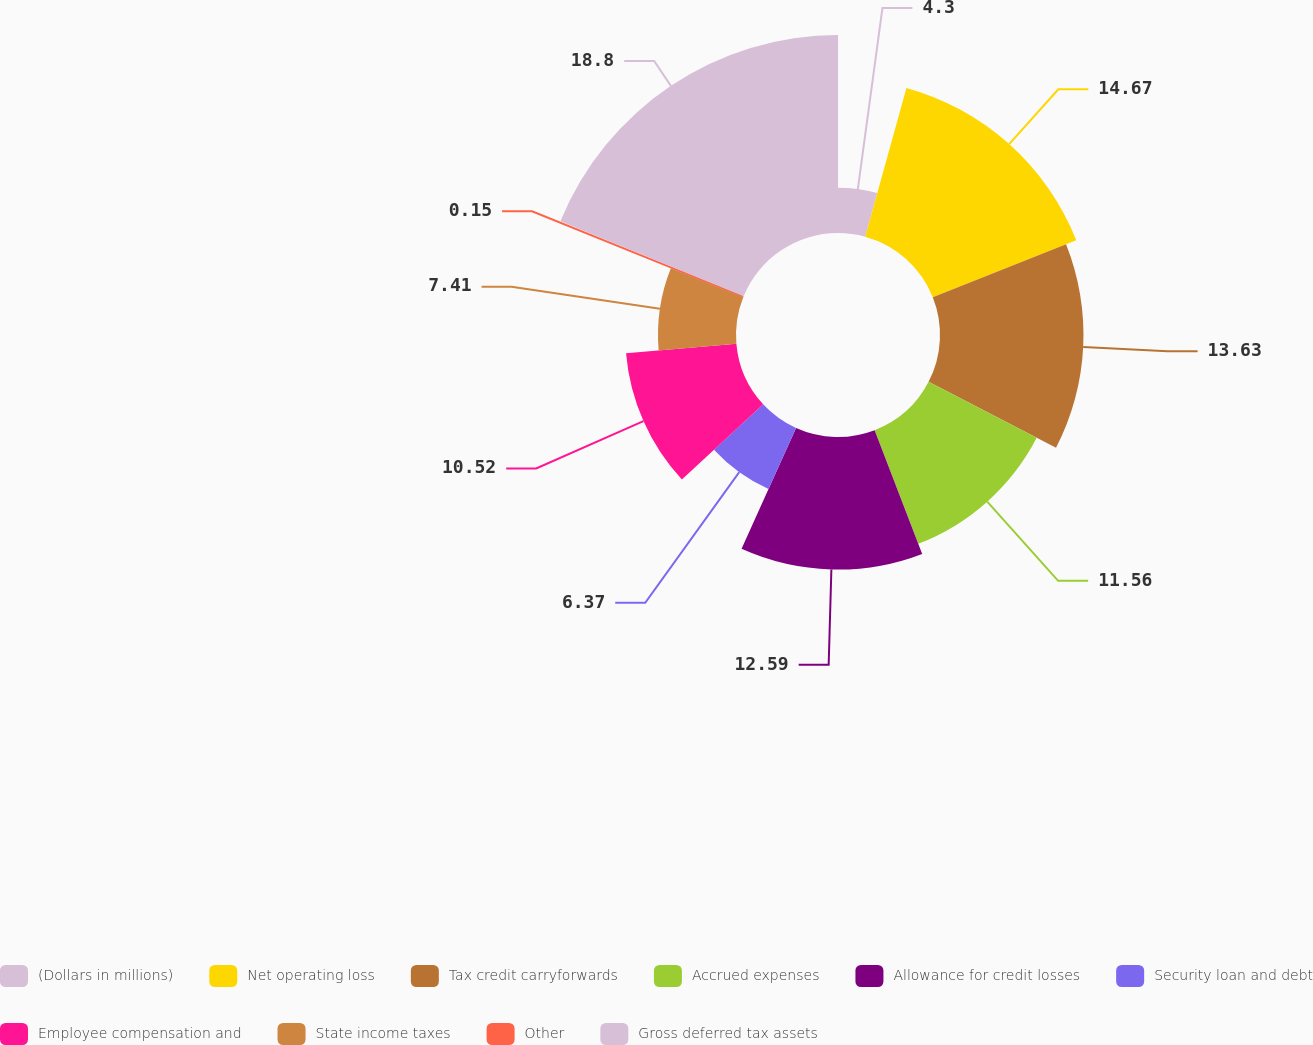Convert chart to OTSL. <chart><loc_0><loc_0><loc_500><loc_500><pie_chart><fcel>(Dollars in millions)<fcel>Net operating loss<fcel>Tax credit carryforwards<fcel>Accrued expenses<fcel>Allowance for credit losses<fcel>Security loan and debt<fcel>Employee compensation and<fcel>State income taxes<fcel>Other<fcel>Gross deferred tax assets<nl><fcel>4.3%<fcel>14.67%<fcel>13.63%<fcel>11.56%<fcel>12.59%<fcel>6.37%<fcel>10.52%<fcel>7.41%<fcel>0.15%<fcel>18.81%<nl></chart> 